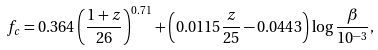Convert formula to latex. <formula><loc_0><loc_0><loc_500><loc_500>f _ { c } = 0 . 3 6 4 \left ( \frac { 1 + z } { 2 6 } \right ) ^ { 0 . 7 1 } + \left ( 0 . 0 1 1 5 \frac { z } { 2 5 } - 0 . 0 4 4 3 \right ) \log \frac { \beta } { 1 0 ^ { - 3 } } ,</formula> 